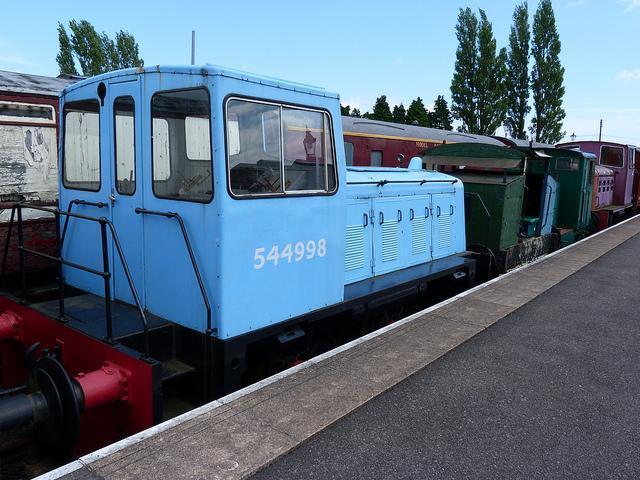How many trains can you see?
Give a very brief answer. 2. How many bananas are pointed left?
Give a very brief answer. 0. 